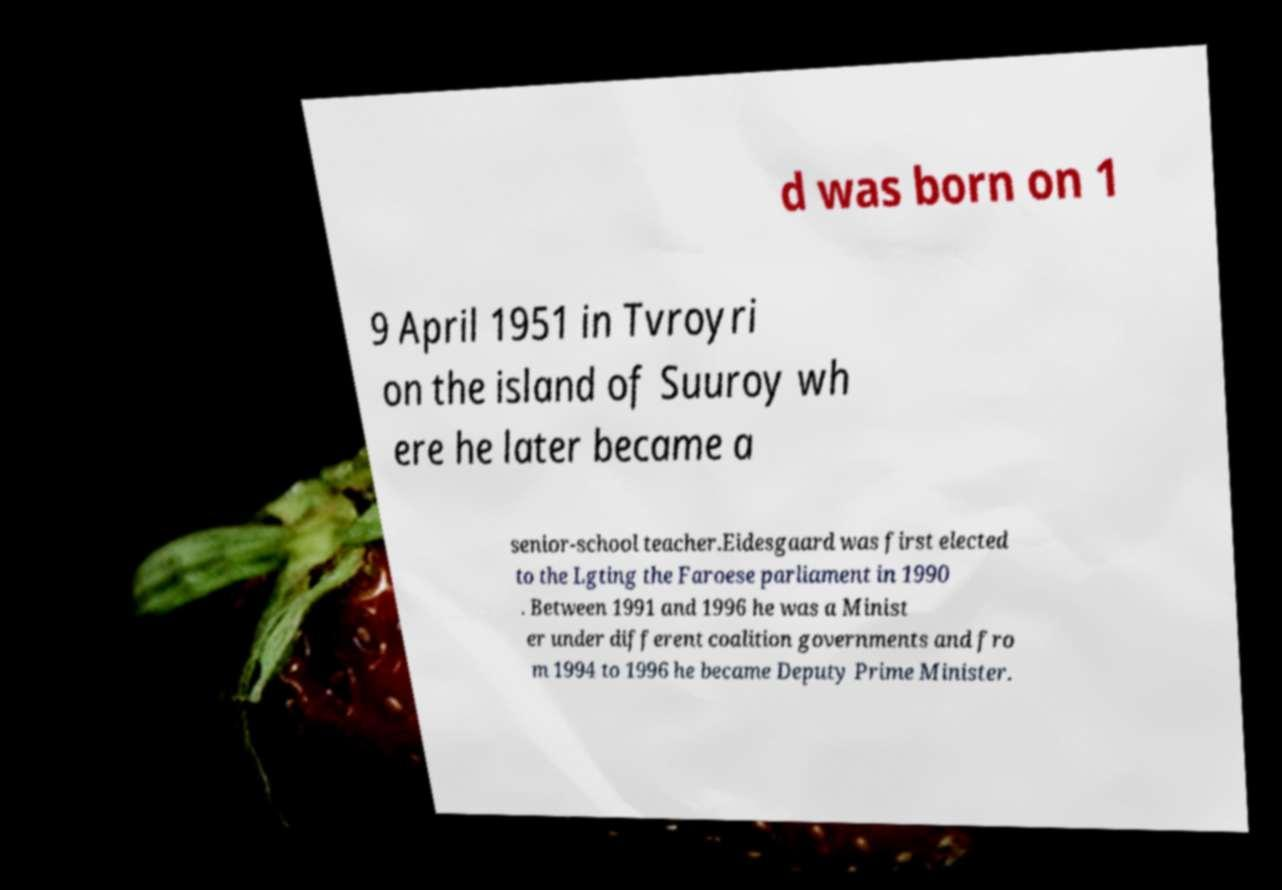What messages or text are displayed in this image? I need them in a readable, typed format. d was born on 1 9 April 1951 in Tvroyri on the island of Suuroy wh ere he later became a senior-school teacher.Eidesgaard was first elected to the Lgting the Faroese parliament in 1990 . Between 1991 and 1996 he was a Minist er under different coalition governments and fro m 1994 to 1996 he became Deputy Prime Minister. 